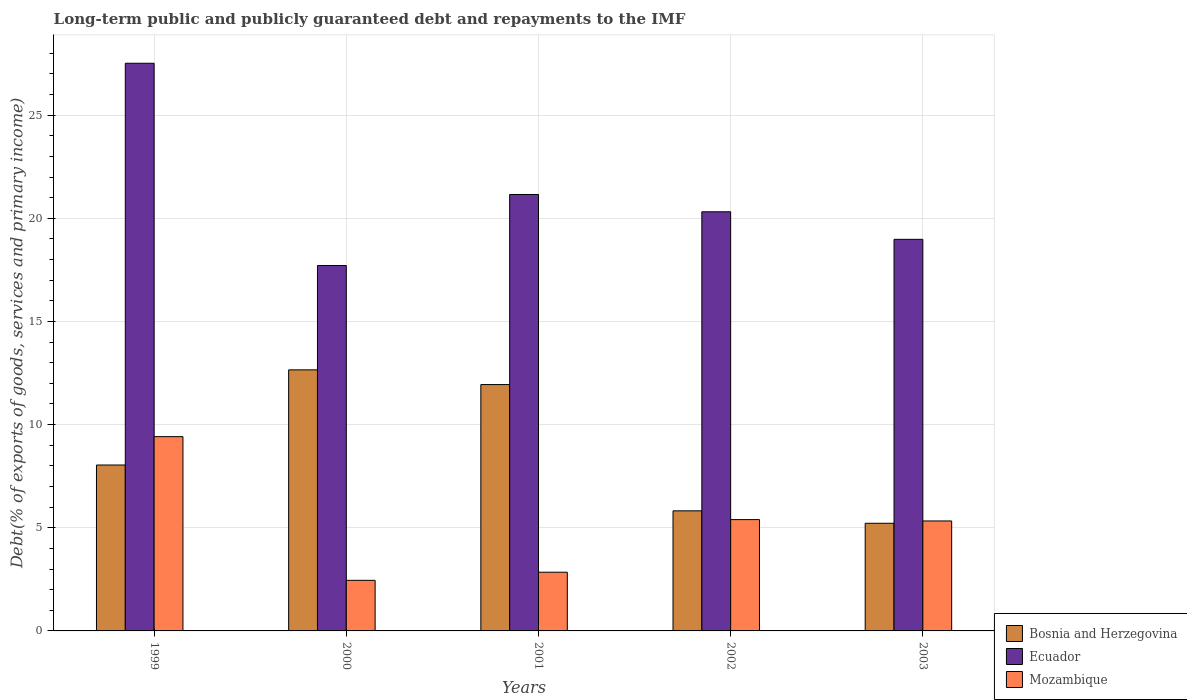How many groups of bars are there?
Give a very brief answer. 5. How many bars are there on the 4th tick from the left?
Keep it short and to the point. 3. What is the debt and repayments in Mozambique in 2002?
Keep it short and to the point. 5.4. Across all years, what is the maximum debt and repayments in Bosnia and Herzegovina?
Provide a short and direct response. 12.65. Across all years, what is the minimum debt and repayments in Mozambique?
Your answer should be very brief. 2.45. What is the total debt and repayments in Mozambique in the graph?
Provide a succinct answer. 25.44. What is the difference between the debt and repayments in Mozambique in 1999 and that in 2002?
Ensure brevity in your answer.  4.02. What is the difference between the debt and repayments in Ecuador in 2002 and the debt and repayments in Mozambique in 1999?
Your answer should be very brief. 10.9. What is the average debt and repayments in Bosnia and Herzegovina per year?
Offer a terse response. 8.73. In the year 2002, what is the difference between the debt and repayments in Ecuador and debt and repayments in Bosnia and Herzegovina?
Provide a succinct answer. 14.5. What is the ratio of the debt and repayments in Bosnia and Herzegovina in 1999 to that in 2000?
Your answer should be very brief. 0.64. Is the difference between the debt and repayments in Ecuador in 2000 and 2002 greater than the difference between the debt and repayments in Bosnia and Herzegovina in 2000 and 2002?
Your answer should be very brief. No. What is the difference between the highest and the second highest debt and repayments in Ecuador?
Provide a succinct answer. 6.36. What is the difference between the highest and the lowest debt and repayments in Mozambique?
Your response must be concise. 6.96. What does the 2nd bar from the left in 2001 represents?
Provide a succinct answer. Ecuador. What does the 1st bar from the right in 2002 represents?
Provide a short and direct response. Mozambique. How many years are there in the graph?
Your answer should be very brief. 5. What is the difference between two consecutive major ticks on the Y-axis?
Offer a very short reply. 5. Does the graph contain grids?
Give a very brief answer. Yes. Where does the legend appear in the graph?
Your response must be concise. Bottom right. What is the title of the graph?
Offer a very short reply. Long-term public and publicly guaranteed debt and repayments to the IMF. What is the label or title of the X-axis?
Offer a terse response. Years. What is the label or title of the Y-axis?
Your answer should be very brief. Debt(% of exports of goods, services and primary income). What is the Debt(% of exports of goods, services and primary income) of Bosnia and Herzegovina in 1999?
Give a very brief answer. 8.04. What is the Debt(% of exports of goods, services and primary income) of Ecuador in 1999?
Ensure brevity in your answer.  27.52. What is the Debt(% of exports of goods, services and primary income) in Mozambique in 1999?
Offer a terse response. 9.42. What is the Debt(% of exports of goods, services and primary income) of Bosnia and Herzegovina in 2000?
Your response must be concise. 12.65. What is the Debt(% of exports of goods, services and primary income) of Ecuador in 2000?
Provide a succinct answer. 17.71. What is the Debt(% of exports of goods, services and primary income) of Mozambique in 2000?
Make the answer very short. 2.45. What is the Debt(% of exports of goods, services and primary income) of Bosnia and Herzegovina in 2001?
Provide a short and direct response. 11.94. What is the Debt(% of exports of goods, services and primary income) of Ecuador in 2001?
Give a very brief answer. 21.15. What is the Debt(% of exports of goods, services and primary income) in Mozambique in 2001?
Provide a succinct answer. 2.85. What is the Debt(% of exports of goods, services and primary income) of Bosnia and Herzegovina in 2002?
Give a very brief answer. 5.82. What is the Debt(% of exports of goods, services and primary income) of Ecuador in 2002?
Make the answer very short. 20.32. What is the Debt(% of exports of goods, services and primary income) in Mozambique in 2002?
Keep it short and to the point. 5.4. What is the Debt(% of exports of goods, services and primary income) in Bosnia and Herzegovina in 2003?
Provide a succinct answer. 5.22. What is the Debt(% of exports of goods, services and primary income) in Ecuador in 2003?
Give a very brief answer. 18.98. What is the Debt(% of exports of goods, services and primary income) of Mozambique in 2003?
Provide a succinct answer. 5.33. Across all years, what is the maximum Debt(% of exports of goods, services and primary income) of Bosnia and Herzegovina?
Your answer should be compact. 12.65. Across all years, what is the maximum Debt(% of exports of goods, services and primary income) in Ecuador?
Offer a terse response. 27.52. Across all years, what is the maximum Debt(% of exports of goods, services and primary income) in Mozambique?
Your response must be concise. 9.42. Across all years, what is the minimum Debt(% of exports of goods, services and primary income) of Bosnia and Herzegovina?
Offer a terse response. 5.22. Across all years, what is the minimum Debt(% of exports of goods, services and primary income) in Ecuador?
Offer a terse response. 17.71. Across all years, what is the minimum Debt(% of exports of goods, services and primary income) in Mozambique?
Your answer should be very brief. 2.45. What is the total Debt(% of exports of goods, services and primary income) of Bosnia and Herzegovina in the graph?
Offer a terse response. 43.67. What is the total Debt(% of exports of goods, services and primary income) of Ecuador in the graph?
Give a very brief answer. 105.68. What is the total Debt(% of exports of goods, services and primary income) of Mozambique in the graph?
Keep it short and to the point. 25.44. What is the difference between the Debt(% of exports of goods, services and primary income) of Bosnia and Herzegovina in 1999 and that in 2000?
Offer a terse response. -4.61. What is the difference between the Debt(% of exports of goods, services and primary income) in Ecuador in 1999 and that in 2000?
Offer a terse response. 9.8. What is the difference between the Debt(% of exports of goods, services and primary income) in Mozambique in 1999 and that in 2000?
Ensure brevity in your answer.  6.96. What is the difference between the Debt(% of exports of goods, services and primary income) in Bosnia and Herzegovina in 1999 and that in 2001?
Provide a short and direct response. -3.9. What is the difference between the Debt(% of exports of goods, services and primary income) of Ecuador in 1999 and that in 2001?
Offer a very short reply. 6.36. What is the difference between the Debt(% of exports of goods, services and primary income) of Mozambique in 1999 and that in 2001?
Your answer should be compact. 6.57. What is the difference between the Debt(% of exports of goods, services and primary income) of Bosnia and Herzegovina in 1999 and that in 2002?
Your answer should be very brief. 2.22. What is the difference between the Debt(% of exports of goods, services and primary income) of Ecuador in 1999 and that in 2002?
Your response must be concise. 7.2. What is the difference between the Debt(% of exports of goods, services and primary income) of Mozambique in 1999 and that in 2002?
Your answer should be very brief. 4.02. What is the difference between the Debt(% of exports of goods, services and primary income) of Bosnia and Herzegovina in 1999 and that in 2003?
Offer a very short reply. 2.82. What is the difference between the Debt(% of exports of goods, services and primary income) in Ecuador in 1999 and that in 2003?
Give a very brief answer. 8.53. What is the difference between the Debt(% of exports of goods, services and primary income) of Mozambique in 1999 and that in 2003?
Give a very brief answer. 4.09. What is the difference between the Debt(% of exports of goods, services and primary income) in Bosnia and Herzegovina in 2000 and that in 2001?
Provide a succinct answer. 0.71. What is the difference between the Debt(% of exports of goods, services and primary income) in Ecuador in 2000 and that in 2001?
Your answer should be compact. -3.44. What is the difference between the Debt(% of exports of goods, services and primary income) of Mozambique in 2000 and that in 2001?
Provide a succinct answer. -0.39. What is the difference between the Debt(% of exports of goods, services and primary income) of Bosnia and Herzegovina in 2000 and that in 2002?
Give a very brief answer. 6.83. What is the difference between the Debt(% of exports of goods, services and primary income) of Ecuador in 2000 and that in 2002?
Your response must be concise. -2.6. What is the difference between the Debt(% of exports of goods, services and primary income) of Mozambique in 2000 and that in 2002?
Provide a short and direct response. -2.94. What is the difference between the Debt(% of exports of goods, services and primary income) of Bosnia and Herzegovina in 2000 and that in 2003?
Your response must be concise. 7.44. What is the difference between the Debt(% of exports of goods, services and primary income) in Ecuador in 2000 and that in 2003?
Your answer should be compact. -1.27. What is the difference between the Debt(% of exports of goods, services and primary income) in Mozambique in 2000 and that in 2003?
Your answer should be compact. -2.88. What is the difference between the Debt(% of exports of goods, services and primary income) in Bosnia and Herzegovina in 2001 and that in 2002?
Ensure brevity in your answer.  6.12. What is the difference between the Debt(% of exports of goods, services and primary income) of Ecuador in 2001 and that in 2002?
Provide a succinct answer. 0.84. What is the difference between the Debt(% of exports of goods, services and primary income) of Mozambique in 2001 and that in 2002?
Your answer should be compact. -2.55. What is the difference between the Debt(% of exports of goods, services and primary income) in Bosnia and Herzegovina in 2001 and that in 2003?
Provide a short and direct response. 6.72. What is the difference between the Debt(% of exports of goods, services and primary income) in Ecuador in 2001 and that in 2003?
Your answer should be very brief. 2.17. What is the difference between the Debt(% of exports of goods, services and primary income) of Mozambique in 2001 and that in 2003?
Offer a very short reply. -2.48. What is the difference between the Debt(% of exports of goods, services and primary income) in Bosnia and Herzegovina in 2002 and that in 2003?
Provide a short and direct response. 0.6. What is the difference between the Debt(% of exports of goods, services and primary income) in Ecuador in 2002 and that in 2003?
Offer a terse response. 1.34. What is the difference between the Debt(% of exports of goods, services and primary income) in Mozambique in 2002 and that in 2003?
Make the answer very short. 0.07. What is the difference between the Debt(% of exports of goods, services and primary income) in Bosnia and Herzegovina in 1999 and the Debt(% of exports of goods, services and primary income) in Ecuador in 2000?
Your answer should be very brief. -9.67. What is the difference between the Debt(% of exports of goods, services and primary income) in Bosnia and Herzegovina in 1999 and the Debt(% of exports of goods, services and primary income) in Mozambique in 2000?
Ensure brevity in your answer.  5.59. What is the difference between the Debt(% of exports of goods, services and primary income) in Ecuador in 1999 and the Debt(% of exports of goods, services and primary income) in Mozambique in 2000?
Provide a succinct answer. 25.06. What is the difference between the Debt(% of exports of goods, services and primary income) of Bosnia and Herzegovina in 1999 and the Debt(% of exports of goods, services and primary income) of Ecuador in 2001?
Offer a terse response. -13.11. What is the difference between the Debt(% of exports of goods, services and primary income) in Bosnia and Herzegovina in 1999 and the Debt(% of exports of goods, services and primary income) in Mozambique in 2001?
Provide a short and direct response. 5.2. What is the difference between the Debt(% of exports of goods, services and primary income) of Ecuador in 1999 and the Debt(% of exports of goods, services and primary income) of Mozambique in 2001?
Your answer should be very brief. 24.67. What is the difference between the Debt(% of exports of goods, services and primary income) in Bosnia and Herzegovina in 1999 and the Debt(% of exports of goods, services and primary income) in Ecuador in 2002?
Offer a terse response. -12.27. What is the difference between the Debt(% of exports of goods, services and primary income) in Bosnia and Herzegovina in 1999 and the Debt(% of exports of goods, services and primary income) in Mozambique in 2002?
Provide a succinct answer. 2.65. What is the difference between the Debt(% of exports of goods, services and primary income) of Ecuador in 1999 and the Debt(% of exports of goods, services and primary income) of Mozambique in 2002?
Ensure brevity in your answer.  22.12. What is the difference between the Debt(% of exports of goods, services and primary income) in Bosnia and Herzegovina in 1999 and the Debt(% of exports of goods, services and primary income) in Ecuador in 2003?
Make the answer very short. -10.94. What is the difference between the Debt(% of exports of goods, services and primary income) in Bosnia and Herzegovina in 1999 and the Debt(% of exports of goods, services and primary income) in Mozambique in 2003?
Keep it short and to the point. 2.71. What is the difference between the Debt(% of exports of goods, services and primary income) in Ecuador in 1999 and the Debt(% of exports of goods, services and primary income) in Mozambique in 2003?
Make the answer very short. 22.19. What is the difference between the Debt(% of exports of goods, services and primary income) in Bosnia and Herzegovina in 2000 and the Debt(% of exports of goods, services and primary income) in Ecuador in 2001?
Make the answer very short. -8.5. What is the difference between the Debt(% of exports of goods, services and primary income) in Bosnia and Herzegovina in 2000 and the Debt(% of exports of goods, services and primary income) in Mozambique in 2001?
Offer a terse response. 9.81. What is the difference between the Debt(% of exports of goods, services and primary income) in Ecuador in 2000 and the Debt(% of exports of goods, services and primary income) in Mozambique in 2001?
Ensure brevity in your answer.  14.87. What is the difference between the Debt(% of exports of goods, services and primary income) of Bosnia and Herzegovina in 2000 and the Debt(% of exports of goods, services and primary income) of Ecuador in 2002?
Provide a succinct answer. -7.66. What is the difference between the Debt(% of exports of goods, services and primary income) of Bosnia and Herzegovina in 2000 and the Debt(% of exports of goods, services and primary income) of Mozambique in 2002?
Give a very brief answer. 7.26. What is the difference between the Debt(% of exports of goods, services and primary income) of Ecuador in 2000 and the Debt(% of exports of goods, services and primary income) of Mozambique in 2002?
Give a very brief answer. 12.32. What is the difference between the Debt(% of exports of goods, services and primary income) of Bosnia and Herzegovina in 2000 and the Debt(% of exports of goods, services and primary income) of Ecuador in 2003?
Give a very brief answer. -6.33. What is the difference between the Debt(% of exports of goods, services and primary income) of Bosnia and Herzegovina in 2000 and the Debt(% of exports of goods, services and primary income) of Mozambique in 2003?
Your answer should be very brief. 7.32. What is the difference between the Debt(% of exports of goods, services and primary income) of Ecuador in 2000 and the Debt(% of exports of goods, services and primary income) of Mozambique in 2003?
Offer a very short reply. 12.38. What is the difference between the Debt(% of exports of goods, services and primary income) of Bosnia and Herzegovina in 2001 and the Debt(% of exports of goods, services and primary income) of Ecuador in 2002?
Your response must be concise. -8.37. What is the difference between the Debt(% of exports of goods, services and primary income) in Bosnia and Herzegovina in 2001 and the Debt(% of exports of goods, services and primary income) in Mozambique in 2002?
Keep it short and to the point. 6.54. What is the difference between the Debt(% of exports of goods, services and primary income) of Ecuador in 2001 and the Debt(% of exports of goods, services and primary income) of Mozambique in 2002?
Provide a succinct answer. 15.76. What is the difference between the Debt(% of exports of goods, services and primary income) of Bosnia and Herzegovina in 2001 and the Debt(% of exports of goods, services and primary income) of Ecuador in 2003?
Give a very brief answer. -7.04. What is the difference between the Debt(% of exports of goods, services and primary income) of Bosnia and Herzegovina in 2001 and the Debt(% of exports of goods, services and primary income) of Mozambique in 2003?
Offer a terse response. 6.61. What is the difference between the Debt(% of exports of goods, services and primary income) in Ecuador in 2001 and the Debt(% of exports of goods, services and primary income) in Mozambique in 2003?
Give a very brief answer. 15.82. What is the difference between the Debt(% of exports of goods, services and primary income) of Bosnia and Herzegovina in 2002 and the Debt(% of exports of goods, services and primary income) of Ecuador in 2003?
Keep it short and to the point. -13.16. What is the difference between the Debt(% of exports of goods, services and primary income) in Bosnia and Herzegovina in 2002 and the Debt(% of exports of goods, services and primary income) in Mozambique in 2003?
Provide a succinct answer. 0.49. What is the difference between the Debt(% of exports of goods, services and primary income) in Ecuador in 2002 and the Debt(% of exports of goods, services and primary income) in Mozambique in 2003?
Give a very brief answer. 14.99. What is the average Debt(% of exports of goods, services and primary income) of Bosnia and Herzegovina per year?
Your answer should be very brief. 8.73. What is the average Debt(% of exports of goods, services and primary income) of Ecuador per year?
Your response must be concise. 21.14. What is the average Debt(% of exports of goods, services and primary income) in Mozambique per year?
Offer a terse response. 5.09. In the year 1999, what is the difference between the Debt(% of exports of goods, services and primary income) of Bosnia and Herzegovina and Debt(% of exports of goods, services and primary income) of Ecuador?
Offer a very short reply. -19.47. In the year 1999, what is the difference between the Debt(% of exports of goods, services and primary income) of Bosnia and Herzegovina and Debt(% of exports of goods, services and primary income) of Mozambique?
Offer a very short reply. -1.37. In the year 1999, what is the difference between the Debt(% of exports of goods, services and primary income) in Ecuador and Debt(% of exports of goods, services and primary income) in Mozambique?
Keep it short and to the point. 18.1. In the year 2000, what is the difference between the Debt(% of exports of goods, services and primary income) of Bosnia and Herzegovina and Debt(% of exports of goods, services and primary income) of Ecuador?
Offer a terse response. -5.06. In the year 2000, what is the difference between the Debt(% of exports of goods, services and primary income) of Bosnia and Herzegovina and Debt(% of exports of goods, services and primary income) of Mozambique?
Provide a succinct answer. 10.2. In the year 2000, what is the difference between the Debt(% of exports of goods, services and primary income) of Ecuador and Debt(% of exports of goods, services and primary income) of Mozambique?
Your response must be concise. 15.26. In the year 2001, what is the difference between the Debt(% of exports of goods, services and primary income) in Bosnia and Herzegovina and Debt(% of exports of goods, services and primary income) in Ecuador?
Your answer should be very brief. -9.21. In the year 2001, what is the difference between the Debt(% of exports of goods, services and primary income) in Bosnia and Herzegovina and Debt(% of exports of goods, services and primary income) in Mozambique?
Ensure brevity in your answer.  9.1. In the year 2001, what is the difference between the Debt(% of exports of goods, services and primary income) in Ecuador and Debt(% of exports of goods, services and primary income) in Mozambique?
Your answer should be compact. 18.31. In the year 2002, what is the difference between the Debt(% of exports of goods, services and primary income) of Bosnia and Herzegovina and Debt(% of exports of goods, services and primary income) of Ecuador?
Provide a short and direct response. -14.5. In the year 2002, what is the difference between the Debt(% of exports of goods, services and primary income) of Bosnia and Herzegovina and Debt(% of exports of goods, services and primary income) of Mozambique?
Your answer should be very brief. 0.42. In the year 2002, what is the difference between the Debt(% of exports of goods, services and primary income) in Ecuador and Debt(% of exports of goods, services and primary income) in Mozambique?
Your answer should be compact. 14.92. In the year 2003, what is the difference between the Debt(% of exports of goods, services and primary income) in Bosnia and Herzegovina and Debt(% of exports of goods, services and primary income) in Ecuador?
Give a very brief answer. -13.76. In the year 2003, what is the difference between the Debt(% of exports of goods, services and primary income) of Bosnia and Herzegovina and Debt(% of exports of goods, services and primary income) of Mozambique?
Make the answer very short. -0.11. In the year 2003, what is the difference between the Debt(% of exports of goods, services and primary income) of Ecuador and Debt(% of exports of goods, services and primary income) of Mozambique?
Offer a terse response. 13.65. What is the ratio of the Debt(% of exports of goods, services and primary income) of Bosnia and Herzegovina in 1999 to that in 2000?
Your answer should be very brief. 0.64. What is the ratio of the Debt(% of exports of goods, services and primary income) in Ecuador in 1999 to that in 2000?
Provide a succinct answer. 1.55. What is the ratio of the Debt(% of exports of goods, services and primary income) of Mozambique in 1999 to that in 2000?
Your response must be concise. 3.84. What is the ratio of the Debt(% of exports of goods, services and primary income) of Bosnia and Herzegovina in 1999 to that in 2001?
Provide a short and direct response. 0.67. What is the ratio of the Debt(% of exports of goods, services and primary income) in Ecuador in 1999 to that in 2001?
Ensure brevity in your answer.  1.3. What is the ratio of the Debt(% of exports of goods, services and primary income) in Mozambique in 1999 to that in 2001?
Offer a terse response. 3.31. What is the ratio of the Debt(% of exports of goods, services and primary income) in Bosnia and Herzegovina in 1999 to that in 2002?
Your response must be concise. 1.38. What is the ratio of the Debt(% of exports of goods, services and primary income) in Ecuador in 1999 to that in 2002?
Your answer should be very brief. 1.35. What is the ratio of the Debt(% of exports of goods, services and primary income) in Mozambique in 1999 to that in 2002?
Ensure brevity in your answer.  1.75. What is the ratio of the Debt(% of exports of goods, services and primary income) of Bosnia and Herzegovina in 1999 to that in 2003?
Your answer should be very brief. 1.54. What is the ratio of the Debt(% of exports of goods, services and primary income) of Ecuador in 1999 to that in 2003?
Offer a terse response. 1.45. What is the ratio of the Debt(% of exports of goods, services and primary income) in Mozambique in 1999 to that in 2003?
Offer a very short reply. 1.77. What is the ratio of the Debt(% of exports of goods, services and primary income) of Bosnia and Herzegovina in 2000 to that in 2001?
Your answer should be compact. 1.06. What is the ratio of the Debt(% of exports of goods, services and primary income) of Ecuador in 2000 to that in 2001?
Offer a very short reply. 0.84. What is the ratio of the Debt(% of exports of goods, services and primary income) in Mozambique in 2000 to that in 2001?
Provide a short and direct response. 0.86. What is the ratio of the Debt(% of exports of goods, services and primary income) of Bosnia and Herzegovina in 2000 to that in 2002?
Your response must be concise. 2.17. What is the ratio of the Debt(% of exports of goods, services and primary income) of Ecuador in 2000 to that in 2002?
Offer a terse response. 0.87. What is the ratio of the Debt(% of exports of goods, services and primary income) in Mozambique in 2000 to that in 2002?
Provide a succinct answer. 0.45. What is the ratio of the Debt(% of exports of goods, services and primary income) of Bosnia and Herzegovina in 2000 to that in 2003?
Provide a succinct answer. 2.43. What is the ratio of the Debt(% of exports of goods, services and primary income) of Ecuador in 2000 to that in 2003?
Your answer should be very brief. 0.93. What is the ratio of the Debt(% of exports of goods, services and primary income) of Mozambique in 2000 to that in 2003?
Provide a short and direct response. 0.46. What is the ratio of the Debt(% of exports of goods, services and primary income) of Bosnia and Herzegovina in 2001 to that in 2002?
Ensure brevity in your answer.  2.05. What is the ratio of the Debt(% of exports of goods, services and primary income) of Ecuador in 2001 to that in 2002?
Ensure brevity in your answer.  1.04. What is the ratio of the Debt(% of exports of goods, services and primary income) of Mozambique in 2001 to that in 2002?
Your answer should be compact. 0.53. What is the ratio of the Debt(% of exports of goods, services and primary income) of Bosnia and Herzegovina in 2001 to that in 2003?
Offer a very short reply. 2.29. What is the ratio of the Debt(% of exports of goods, services and primary income) in Ecuador in 2001 to that in 2003?
Keep it short and to the point. 1.11. What is the ratio of the Debt(% of exports of goods, services and primary income) in Mozambique in 2001 to that in 2003?
Your answer should be very brief. 0.53. What is the ratio of the Debt(% of exports of goods, services and primary income) in Bosnia and Herzegovina in 2002 to that in 2003?
Give a very brief answer. 1.12. What is the ratio of the Debt(% of exports of goods, services and primary income) in Ecuador in 2002 to that in 2003?
Your answer should be very brief. 1.07. What is the ratio of the Debt(% of exports of goods, services and primary income) of Mozambique in 2002 to that in 2003?
Your answer should be compact. 1.01. What is the difference between the highest and the second highest Debt(% of exports of goods, services and primary income) of Bosnia and Herzegovina?
Give a very brief answer. 0.71. What is the difference between the highest and the second highest Debt(% of exports of goods, services and primary income) of Ecuador?
Your answer should be compact. 6.36. What is the difference between the highest and the second highest Debt(% of exports of goods, services and primary income) of Mozambique?
Ensure brevity in your answer.  4.02. What is the difference between the highest and the lowest Debt(% of exports of goods, services and primary income) in Bosnia and Herzegovina?
Offer a very short reply. 7.44. What is the difference between the highest and the lowest Debt(% of exports of goods, services and primary income) of Ecuador?
Provide a short and direct response. 9.8. What is the difference between the highest and the lowest Debt(% of exports of goods, services and primary income) of Mozambique?
Provide a succinct answer. 6.96. 